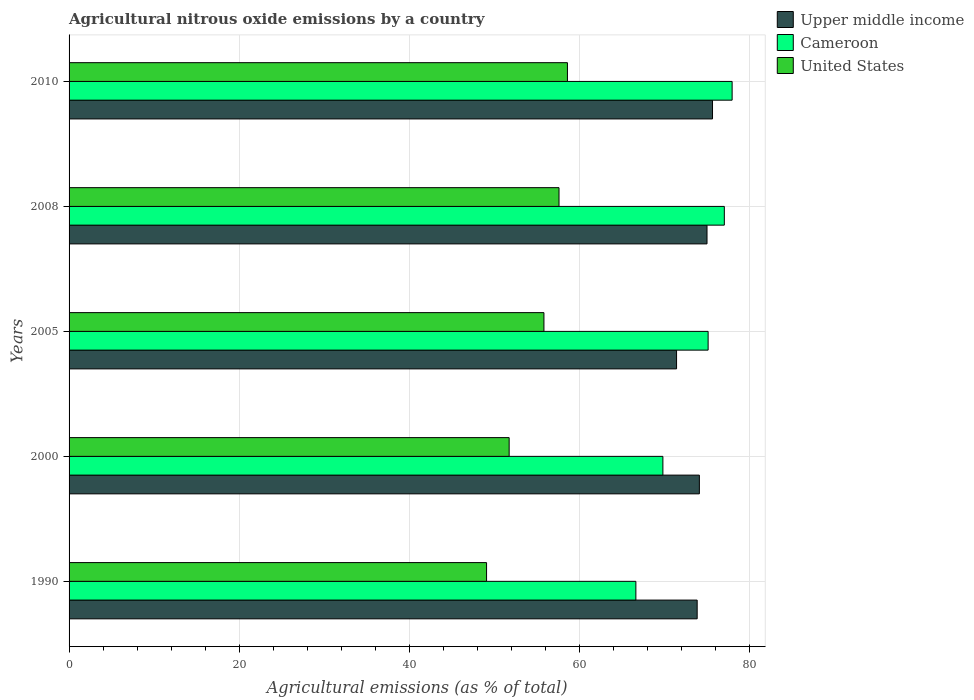How many different coloured bars are there?
Make the answer very short. 3. How many bars are there on the 5th tick from the bottom?
Your answer should be compact. 3. What is the amount of agricultural nitrous oxide emitted in United States in 2010?
Provide a short and direct response. 58.59. Across all years, what is the maximum amount of agricultural nitrous oxide emitted in United States?
Provide a short and direct response. 58.59. Across all years, what is the minimum amount of agricultural nitrous oxide emitted in Cameroon?
Offer a very short reply. 66.63. What is the total amount of agricultural nitrous oxide emitted in Cameroon in the graph?
Make the answer very short. 366.55. What is the difference between the amount of agricultural nitrous oxide emitted in Cameroon in 2000 and that in 2005?
Give a very brief answer. -5.32. What is the difference between the amount of agricultural nitrous oxide emitted in Upper middle income in 2005 and the amount of agricultural nitrous oxide emitted in United States in 2008?
Offer a terse response. 13.82. What is the average amount of agricultural nitrous oxide emitted in United States per year?
Your answer should be very brief. 54.57. In the year 2005, what is the difference between the amount of agricultural nitrous oxide emitted in United States and amount of agricultural nitrous oxide emitted in Cameroon?
Provide a succinct answer. -19.3. What is the ratio of the amount of agricultural nitrous oxide emitted in Cameroon in 2000 to that in 2008?
Ensure brevity in your answer.  0.91. Is the difference between the amount of agricultural nitrous oxide emitted in United States in 2000 and 2008 greater than the difference between the amount of agricultural nitrous oxide emitted in Cameroon in 2000 and 2008?
Your answer should be very brief. Yes. What is the difference between the highest and the second highest amount of agricultural nitrous oxide emitted in Cameroon?
Keep it short and to the point. 0.92. What is the difference between the highest and the lowest amount of agricultural nitrous oxide emitted in Cameroon?
Offer a terse response. 11.31. What does the 2nd bar from the top in 2005 represents?
Give a very brief answer. Cameroon. What does the 3rd bar from the bottom in 2010 represents?
Keep it short and to the point. United States. How many bars are there?
Give a very brief answer. 15. Are all the bars in the graph horizontal?
Offer a terse response. Yes. How many years are there in the graph?
Provide a short and direct response. 5. What is the difference between two consecutive major ticks on the X-axis?
Your response must be concise. 20. Are the values on the major ticks of X-axis written in scientific E-notation?
Keep it short and to the point. No. Does the graph contain any zero values?
Keep it short and to the point. No. Does the graph contain grids?
Your response must be concise. Yes. Where does the legend appear in the graph?
Provide a short and direct response. Top right. How many legend labels are there?
Offer a terse response. 3. What is the title of the graph?
Make the answer very short. Agricultural nitrous oxide emissions by a country. What is the label or title of the X-axis?
Your answer should be compact. Agricultural emissions (as % of total). What is the Agricultural emissions (as % of total) in Upper middle income in 1990?
Offer a very short reply. 73.84. What is the Agricultural emissions (as % of total) in Cameroon in 1990?
Provide a short and direct response. 66.63. What is the Agricultural emissions (as % of total) of United States in 1990?
Your answer should be very brief. 49.08. What is the Agricultural emissions (as % of total) of Upper middle income in 2000?
Your answer should be very brief. 74.1. What is the Agricultural emissions (as % of total) in Cameroon in 2000?
Keep it short and to the point. 69.81. What is the Agricultural emissions (as % of total) of United States in 2000?
Your answer should be very brief. 51.74. What is the Agricultural emissions (as % of total) of Upper middle income in 2005?
Give a very brief answer. 71.42. What is the Agricultural emissions (as % of total) of Cameroon in 2005?
Keep it short and to the point. 75.13. What is the Agricultural emissions (as % of total) of United States in 2005?
Keep it short and to the point. 55.83. What is the Agricultural emissions (as % of total) in Upper middle income in 2008?
Your answer should be very brief. 75. What is the Agricultural emissions (as % of total) of Cameroon in 2008?
Offer a terse response. 77.03. What is the Agricultural emissions (as % of total) in United States in 2008?
Ensure brevity in your answer.  57.6. What is the Agricultural emissions (as % of total) of Upper middle income in 2010?
Make the answer very short. 75.64. What is the Agricultural emissions (as % of total) of Cameroon in 2010?
Make the answer very short. 77.95. What is the Agricultural emissions (as % of total) of United States in 2010?
Give a very brief answer. 58.59. Across all years, what is the maximum Agricultural emissions (as % of total) of Upper middle income?
Your answer should be very brief. 75.64. Across all years, what is the maximum Agricultural emissions (as % of total) in Cameroon?
Keep it short and to the point. 77.95. Across all years, what is the maximum Agricultural emissions (as % of total) of United States?
Provide a short and direct response. 58.59. Across all years, what is the minimum Agricultural emissions (as % of total) in Upper middle income?
Provide a succinct answer. 71.42. Across all years, what is the minimum Agricultural emissions (as % of total) in Cameroon?
Keep it short and to the point. 66.63. Across all years, what is the minimum Agricultural emissions (as % of total) in United States?
Offer a terse response. 49.08. What is the total Agricultural emissions (as % of total) in Upper middle income in the graph?
Provide a short and direct response. 370. What is the total Agricultural emissions (as % of total) in Cameroon in the graph?
Offer a very short reply. 366.55. What is the total Agricultural emissions (as % of total) of United States in the graph?
Your response must be concise. 272.83. What is the difference between the Agricultural emissions (as % of total) in Upper middle income in 1990 and that in 2000?
Provide a succinct answer. -0.26. What is the difference between the Agricultural emissions (as % of total) in Cameroon in 1990 and that in 2000?
Your response must be concise. -3.18. What is the difference between the Agricultural emissions (as % of total) in United States in 1990 and that in 2000?
Provide a short and direct response. -2.66. What is the difference between the Agricultural emissions (as % of total) in Upper middle income in 1990 and that in 2005?
Provide a succinct answer. 2.42. What is the difference between the Agricultural emissions (as % of total) in Cameroon in 1990 and that in 2005?
Provide a succinct answer. -8.49. What is the difference between the Agricultural emissions (as % of total) of United States in 1990 and that in 2005?
Ensure brevity in your answer.  -6.75. What is the difference between the Agricultural emissions (as % of total) in Upper middle income in 1990 and that in 2008?
Ensure brevity in your answer.  -1.16. What is the difference between the Agricultural emissions (as % of total) of Cameroon in 1990 and that in 2008?
Ensure brevity in your answer.  -10.4. What is the difference between the Agricultural emissions (as % of total) in United States in 1990 and that in 2008?
Provide a succinct answer. -8.52. What is the difference between the Agricultural emissions (as % of total) of Upper middle income in 1990 and that in 2010?
Give a very brief answer. -1.8. What is the difference between the Agricultural emissions (as % of total) in Cameroon in 1990 and that in 2010?
Your answer should be compact. -11.31. What is the difference between the Agricultural emissions (as % of total) of United States in 1990 and that in 2010?
Provide a short and direct response. -9.51. What is the difference between the Agricultural emissions (as % of total) in Upper middle income in 2000 and that in 2005?
Give a very brief answer. 2.68. What is the difference between the Agricultural emissions (as % of total) in Cameroon in 2000 and that in 2005?
Provide a succinct answer. -5.32. What is the difference between the Agricultural emissions (as % of total) of United States in 2000 and that in 2005?
Your answer should be compact. -4.09. What is the difference between the Agricultural emissions (as % of total) of Upper middle income in 2000 and that in 2008?
Your answer should be very brief. -0.9. What is the difference between the Agricultural emissions (as % of total) in Cameroon in 2000 and that in 2008?
Provide a short and direct response. -7.22. What is the difference between the Agricultural emissions (as % of total) of United States in 2000 and that in 2008?
Give a very brief answer. -5.86. What is the difference between the Agricultural emissions (as % of total) of Upper middle income in 2000 and that in 2010?
Provide a short and direct response. -1.54. What is the difference between the Agricultural emissions (as % of total) of Cameroon in 2000 and that in 2010?
Your answer should be very brief. -8.14. What is the difference between the Agricultural emissions (as % of total) of United States in 2000 and that in 2010?
Make the answer very short. -6.85. What is the difference between the Agricultural emissions (as % of total) in Upper middle income in 2005 and that in 2008?
Give a very brief answer. -3.58. What is the difference between the Agricultural emissions (as % of total) of Cameroon in 2005 and that in 2008?
Your answer should be very brief. -1.9. What is the difference between the Agricultural emissions (as % of total) of United States in 2005 and that in 2008?
Ensure brevity in your answer.  -1.77. What is the difference between the Agricultural emissions (as % of total) of Upper middle income in 2005 and that in 2010?
Offer a terse response. -4.23. What is the difference between the Agricultural emissions (as % of total) in Cameroon in 2005 and that in 2010?
Offer a very short reply. -2.82. What is the difference between the Agricultural emissions (as % of total) in United States in 2005 and that in 2010?
Provide a short and direct response. -2.76. What is the difference between the Agricultural emissions (as % of total) in Upper middle income in 2008 and that in 2010?
Provide a succinct answer. -0.65. What is the difference between the Agricultural emissions (as % of total) in Cameroon in 2008 and that in 2010?
Give a very brief answer. -0.92. What is the difference between the Agricultural emissions (as % of total) of United States in 2008 and that in 2010?
Provide a short and direct response. -0.99. What is the difference between the Agricultural emissions (as % of total) in Upper middle income in 1990 and the Agricultural emissions (as % of total) in Cameroon in 2000?
Ensure brevity in your answer.  4.03. What is the difference between the Agricultural emissions (as % of total) in Upper middle income in 1990 and the Agricultural emissions (as % of total) in United States in 2000?
Your answer should be very brief. 22.1. What is the difference between the Agricultural emissions (as % of total) of Cameroon in 1990 and the Agricultural emissions (as % of total) of United States in 2000?
Make the answer very short. 14.9. What is the difference between the Agricultural emissions (as % of total) of Upper middle income in 1990 and the Agricultural emissions (as % of total) of Cameroon in 2005?
Your response must be concise. -1.29. What is the difference between the Agricultural emissions (as % of total) in Upper middle income in 1990 and the Agricultural emissions (as % of total) in United States in 2005?
Your answer should be very brief. 18.01. What is the difference between the Agricultural emissions (as % of total) in Cameroon in 1990 and the Agricultural emissions (as % of total) in United States in 2005?
Provide a succinct answer. 10.81. What is the difference between the Agricultural emissions (as % of total) of Upper middle income in 1990 and the Agricultural emissions (as % of total) of Cameroon in 2008?
Offer a very short reply. -3.19. What is the difference between the Agricultural emissions (as % of total) of Upper middle income in 1990 and the Agricultural emissions (as % of total) of United States in 2008?
Keep it short and to the point. 16.24. What is the difference between the Agricultural emissions (as % of total) in Cameroon in 1990 and the Agricultural emissions (as % of total) in United States in 2008?
Make the answer very short. 9.04. What is the difference between the Agricultural emissions (as % of total) in Upper middle income in 1990 and the Agricultural emissions (as % of total) in Cameroon in 2010?
Your response must be concise. -4.11. What is the difference between the Agricultural emissions (as % of total) of Upper middle income in 1990 and the Agricultural emissions (as % of total) of United States in 2010?
Offer a very short reply. 15.25. What is the difference between the Agricultural emissions (as % of total) in Cameroon in 1990 and the Agricultural emissions (as % of total) in United States in 2010?
Your response must be concise. 8.04. What is the difference between the Agricultural emissions (as % of total) in Upper middle income in 2000 and the Agricultural emissions (as % of total) in Cameroon in 2005?
Provide a short and direct response. -1.03. What is the difference between the Agricultural emissions (as % of total) in Upper middle income in 2000 and the Agricultural emissions (as % of total) in United States in 2005?
Provide a succinct answer. 18.27. What is the difference between the Agricultural emissions (as % of total) of Cameroon in 2000 and the Agricultural emissions (as % of total) of United States in 2005?
Offer a very short reply. 13.98. What is the difference between the Agricultural emissions (as % of total) in Upper middle income in 2000 and the Agricultural emissions (as % of total) in Cameroon in 2008?
Make the answer very short. -2.93. What is the difference between the Agricultural emissions (as % of total) of Upper middle income in 2000 and the Agricultural emissions (as % of total) of United States in 2008?
Your response must be concise. 16.5. What is the difference between the Agricultural emissions (as % of total) in Cameroon in 2000 and the Agricultural emissions (as % of total) in United States in 2008?
Keep it short and to the point. 12.21. What is the difference between the Agricultural emissions (as % of total) of Upper middle income in 2000 and the Agricultural emissions (as % of total) of Cameroon in 2010?
Keep it short and to the point. -3.85. What is the difference between the Agricultural emissions (as % of total) of Upper middle income in 2000 and the Agricultural emissions (as % of total) of United States in 2010?
Offer a terse response. 15.51. What is the difference between the Agricultural emissions (as % of total) in Cameroon in 2000 and the Agricultural emissions (as % of total) in United States in 2010?
Your answer should be very brief. 11.22. What is the difference between the Agricultural emissions (as % of total) of Upper middle income in 2005 and the Agricultural emissions (as % of total) of Cameroon in 2008?
Offer a very short reply. -5.61. What is the difference between the Agricultural emissions (as % of total) in Upper middle income in 2005 and the Agricultural emissions (as % of total) in United States in 2008?
Offer a very short reply. 13.82. What is the difference between the Agricultural emissions (as % of total) of Cameroon in 2005 and the Agricultural emissions (as % of total) of United States in 2008?
Your response must be concise. 17.53. What is the difference between the Agricultural emissions (as % of total) of Upper middle income in 2005 and the Agricultural emissions (as % of total) of Cameroon in 2010?
Your answer should be compact. -6.53. What is the difference between the Agricultural emissions (as % of total) of Upper middle income in 2005 and the Agricultural emissions (as % of total) of United States in 2010?
Your answer should be compact. 12.83. What is the difference between the Agricultural emissions (as % of total) of Cameroon in 2005 and the Agricultural emissions (as % of total) of United States in 2010?
Your answer should be compact. 16.54. What is the difference between the Agricultural emissions (as % of total) in Upper middle income in 2008 and the Agricultural emissions (as % of total) in Cameroon in 2010?
Provide a succinct answer. -2.95. What is the difference between the Agricultural emissions (as % of total) in Upper middle income in 2008 and the Agricultural emissions (as % of total) in United States in 2010?
Ensure brevity in your answer.  16.41. What is the difference between the Agricultural emissions (as % of total) of Cameroon in 2008 and the Agricultural emissions (as % of total) of United States in 2010?
Your answer should be very brief. 18.44. What is the average Agricultural emissions (as % of total) of Upper middle income per year?
Provide a short and direct response. 74. What is the average Agricultural emissions (as % of total) of Cameroon per year?
Make the answer very short. 73.31. What is the average Agricultural emissions (as % of total) of United States per year?
Keep it short and to the point. 54.57. In the year 1990, what is the difference between the Agricultural emissions (as % of total) of Upper middle income and Agricultural emissions (as % of total) of Cameroon?
Your answer should be very brief. 7.21. In the year 1990, what is the difference between the Agricultural emissions (as % of total) in Upper middle income and Agricultural emissions (as % of total) in United States?
Offer a very short reply. 24.76. In the year 1990, what is the difference between the Agricultural emissions (as % of total) in Cameroon and Agricultural emissions (as % of total) in United States?
Give a very brief answer. 17.55. In the year 2000, what is the difference between the Agricultural emissions (as % of total) of Upper middle income and Agricultural emissions (as % of total) of Cameroon?
Your response must be concise. 4.29. In the year 2000, what is the difference between the Agricultural emissions (as % of total) of Upper middle income and Agricultural emissions (as % of total) of United States?
Make the answer very short. 22.36. In the year 2000, what is the difference between the Agricultural emissions (as % of total) in Cameroon and Agricultural emissions (as % of total) in United States?
Give a very brief answer. 18.07. In the year 2005, what is the difference between the Agricultural emissions (as % of total) of Upper middle income and Agricultural emissions (as % of total) of Cameroon?
Provide a succinct answer. -3.71. In the year 2005, what is the difference between the Agricultural emissions (as % of total) of Upper middle income and Agricultural emissions (as % of total) of United States?
Offer a terse response. 15.59. In the year 2005, what is the difference between the Agricultural emissions (as % of total) in Cameroon and Agricultural emissions (as % of total) in United States?
Give a very brief answer. 19.3. In the year 2008, what is the difference between the Agricultural emissions (as % of total) in Upper middle income and Agricultural emissions (as % of total) in Cameroon?
Provide a short and direct response. -2.04. In the year 2008, what is the difference between the Agricultural emissions (as % of total) in Upper middle income and Agricultural emissions (as % of total) in United States?
Make the answer very short. 17.4. In the year 2008, what is the difference between the Agricultural emissions (as % of total) in Cameroon and Agricultural emissions (as % of total) in United States?
Offer a terse response. 19.43. In the year 2010, what is the difference between the Agricultural emissions (as % of total) of Upper middle income and Agricultural emissions (as % of total) of Cameroon?
Offer a very short reply. -2.31. In the year 2010, what is the difference between the Agricultural emissions (as % of total) of Upper middle income and Agricultural emissions (as % of total) of United States?
Make the answer very short. 17.05. In the year 2010, what is the difference between the Agricultural emissions (as % of total) of Cameroon and Agricultural emissions (as % of total) of United States?
Your response must be concise. 19.36. What is the ratio of the Agricultural emissions (as % of total) of Upper middle income in 1990 to that in 2000?
Provide a short and direct response. 1. What is the ratio of the Agricultural emissions (as % of total) in Cameroon in 1990 to that in 2000?
Ensure brevity in your answer.  0.95. What is the ratio of the Agricultural emissions (as % of total) of United States in 1990 to that in 2000?
Keep it short and to the point. 0.95. What is the ratio of the Agricultural emissions (as % of total) in Upper middle income in 1990 to that in 2005?
Make the answer very short. 1.03. What is the ratio of the Agricultural emissions (as % of total) in Cameroon in 1990 to that in 2005?
Offer a very short reply. 0.89. What is the ratio of the Agricultural emissions (as % of total) of United States in 1990 to that in 2005?
Keep it short and to the point. 0.88. What is the ratio of the Agricultural emissions (as % of total) in Upper middle income in 1990 to that in 2008?
Offer a very short reply. 0.98. What is the ratio of the Agricultural emissions (as % of total) in Cameroon in 1990 to that in 2008?
Provide a short and direct response. 0.86. What is the ratio of the Agricultural emissions (as % of total) of United States in 1990 to that in 2008?
Your response must be concise. 0.85. What is the ratio of the Agricultural emissions (as % of total) of Upper middle income in 1990 to that in 2010?
Keep it short and to the point. 0.98. What is the ratio of the Agricultural emissions (as % of total) in Cameroon in 1990 to that in 2010?
Ensure brevity in your answer.  0.85. What is the ratio of the Agricultural emissions (as % of total) of United States in 1990 to that in 2010?
Make the answer very short. 0.84. What is the ratio of the Agricultural emissions (as % of total) of Upper middle income in 2000 to that in 2005?
Ensure brevity in your answer.  1.04. What is the ratio of the Agricultural emissions (as % of total) of Cameroon in 2000 to that in 2005?
Provide a short and direct response. 0.93. What is the ratio of the Agricultural emissions (as % of total) in United States in 2000 to that in 2005?
Provide a succinct answer. 0.93. What is the ratio of the Agricultural emissions (as % of total) of Cameroon in 2000 to that in 2008?
Ensure brevity in your answer.  0.91. What is the ratio of the Agricultural emissions (as % of total) in United States in 2000 to that in 2008?
Make the answer very short. 0.9. What is the ratio of the Agricultural emissions (as % of total) in Upper middle income in 2000 to that in 2010?
Provide a short and direct response. 0.98. What is the ratio of the Agricultural emissions (as % of total) in Cameroon in 2000 to that in 2010?
Provide a succinct answer. 0.9. What is the ratio of the Agricultural emissions (as % of total) of United States in 2000 to that in 2010?
Give a very brief answer. 0.88. What is the ratio of the Agricultural emissions (as % of total) in Upper middle income in 2005 to that in 2008?
Ensure brevity in your answer.  0.95. What is the ratio of the Agricultural emissions (as % of total) in Cameroon in 2005 to that in 2008?
Provide a succinct answer. 0.98. What is the ratio of the Agricultural emissions (as % of total) in United States in 2005 to that in 2008?
Provide a succinct answer. 0.97. What is the ratio of the Agricultural emissions (as % of total) of Upper middle income in 2005 to that in 2010?
Your response must be concise. 0.94. What is the ratio of the Agricultural emissions (as % of total) in Cameroon in 2005 to that in 2010?
Give a very brief answer. 0.96. What is the ratio of the Agricultural emissions (as % of total) in United States in 2005 to that in 2010?
Give a very brief answer. 0.95. What is the ratio of the Agricultural emissions (as % of total) in Cameroon in 2008 to that in 2010?
Provide a succinct answer. 0.99. What is the ratio of the Agricultural emissions (as % of total) in United States in 2008 to that in 2010?
Your response must be concise. 0.98. What is the difference between the highest and the second highest Agricultural emissions (as % of total) in Upper middle income?
Make the answer very short. 0.65. What is the difference between the highest and the second highest Agricultural emissions (as % of total) in Cameroon?
Provide a succinct answer. 0.92. What is the difference between the highest and the lowest Agricultural emissions (as % of total) in Upper middle income?
Make the answer very short. 4.23. What is the difference between the highest and the lowest Agricultural emissions (as % of total) of Cameroon?
Make the answer very short. 11.31. What is the difference between the highest and the lowest Agricultural emissions (as % of total) of United States?
Your answer should be compact. 9.51. 